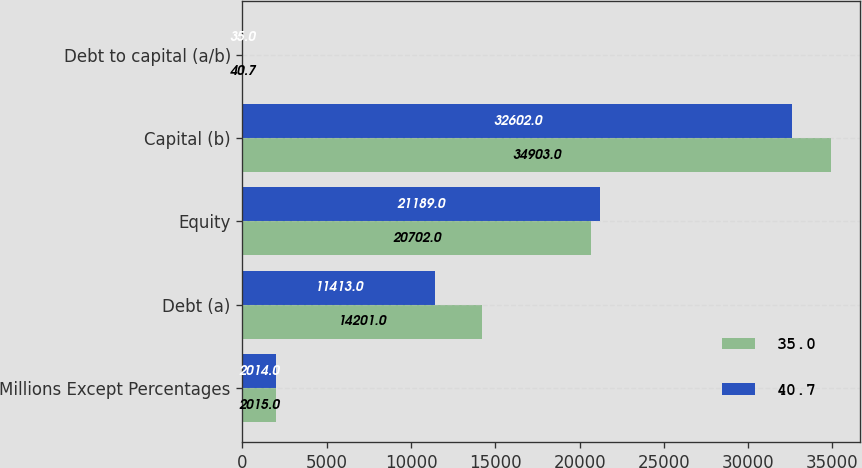<chart> <loc_0><loc_0><loc_500><loc_500><stacked_bar_chart><ecel><fcel>Millions Except Percentages<fcel>Debt (a)<fcel>Equity<fcel>Capital (b)<fcel>Debt to capital (a/b)<nl><fcel>35<fcel>2015<fcel>14201<fcel>20702<fcel>34903<fcel>40.7<nl><fcel>40.7<fcel>2014<fcel>11413<fcel>21189<fcel>32602<fcel>35<nl></chart> 